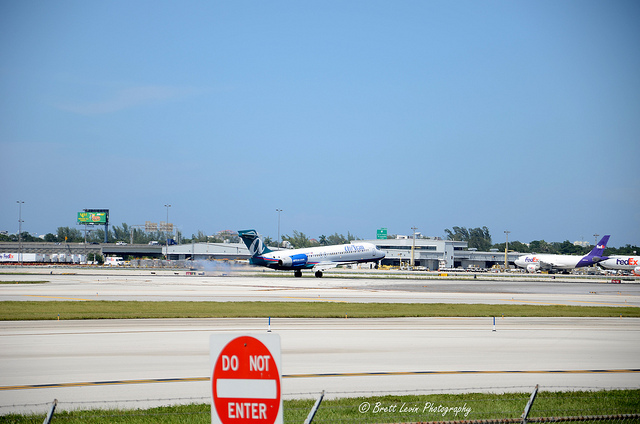What does the sign in front of the runways near the camera say?
A. dead end
B. enter
C. one way
D. stop
Answer with the option's letter from the given choices directly. B What color is the FedEx airplane's tail fin?
A. yellow
B. purple
C. blue
D. green B 